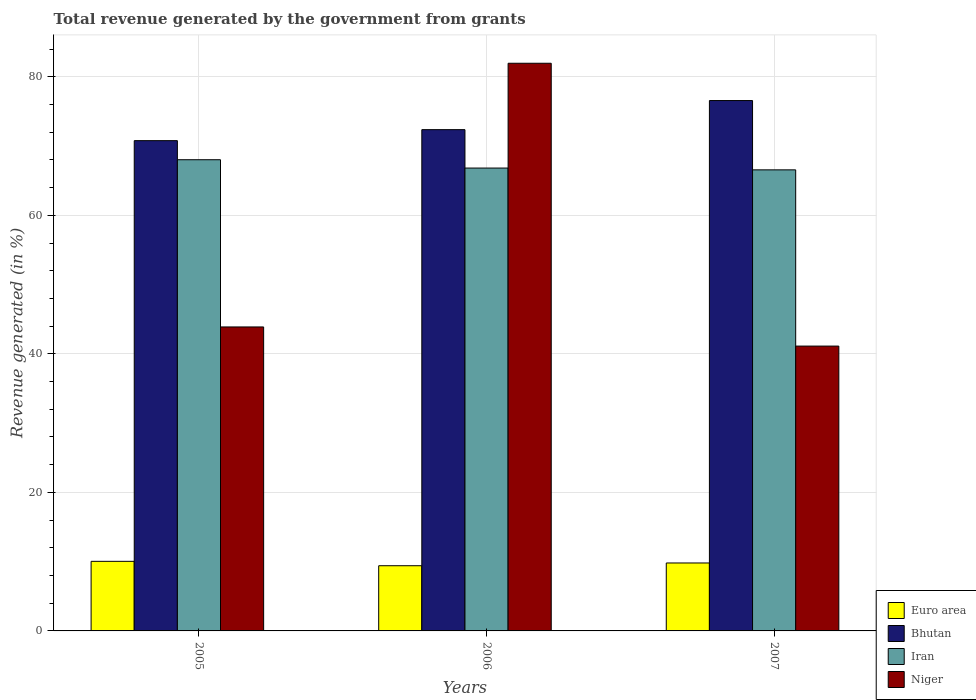How many groups of bars are there?
Your response must be concise. 3. Are the number of bars on each tick of the X-axis equal?
Your answer should be compact. Yes. How many bars are there on the 3rd tick from the left?
Provide a short and direct response. 4. How many bars are there on the 3rd tick from the right?
Make the answer very short. 4. What is the label of the 1st group of bars from the left?
Your response must be concise. 2005. What is the total revenue generated in Euro area in 2007?
Offer a very short reply. 9.81. Across all years, what is the maximum total revenue generated in Bhutan?
Offer a very short reply. 76.57. Across all years, what is the minimum total revenue generated in Niger?
Provide a short and direct response. 41.12. In which year was the total revenue generated in Niger maximum?
Provide a succinct answer. 2006. In which year was the total revenue generated in Iran minimum?
Your answer should be compact. 2007. What is the total total revenue generated in Iran in the graph?
Your answer should be compact. 201.42. What is the difference between the total revenue generated in Iran in 2006 and that in 2007?
Offer a terse response. 0.26. What is the difference between the total revenue generated in Bhutan in 2005 and the total revenue generated in Iran in 2006?
Your answer should be very brief. 3.96. What is the average total revenue generated in Bhutan per year?
Provide a succinct answer. 73.24. In the year 2006, what is the difference between the total revenue generated in Euro area and total revenue generated in Niger?
Ensure brevity in your answer.  -72.54. In how many years, is the total revenue generated in Niger greater than 20 %?
Offer a terse response. 3. What is the ratio of the total revenue generated in Iran in 2005 to that in 2007?
Provide a short and direct response. 1.02. Is the total revenue generated in Niger in 2005 less than that in 2006?
Provide a succinct answer. Yes. What is the difference between the highest and the second highest total revenue generated in Euro area?
Offer a terse response. 0.24. What is the difference between the highest and the lowest total revenue generated in Bhutan?
Offer a terse response. 5.79. Is the sum of the total revenue generated in Bhutan in 2006 and 2007 greater than the maximum total revenue generated in Niger across all years?
Give a very brief answer. Yes. What does the 3rd bar from the left in 2005 represents?
Ensure brevity in your answer.  Iran. What does the 2nd bar from the right in 2007 represents?
Your response must be concise. Iran. How many years are there in the graph?
Offer a very short reply. 3. Where does the legend appear in the graph?
Your answer should be very brief. Bottom right. How many legend labels are there?
Offer a terse response. 4. What is the title of the graph?
Provide a short and direct response. Total revenue generated by the government from grants. What is the label or title of the Y-axis?
Give a very brief answer. Revenue generated (in %). What is the Revenue generated (in %) in Euro area in 2005?
Give a very brief answer. 10.05. What is the Revenue generated (in %) of Bhutan in 2005?
Offer a very short reply. 70.78. What is the Revenue generated (in %) in Iran in 2005?
Your answer should be very brief. 68.03. What is the Revenue generated (in %) of Niger in 2005?
Provide a short and direct response. 43.89. What is the Revenue generated (in %) in Euro area in 2006?
Provide a succinct answer. 9.41. What is the Revenue generated (in %) of Bhutan in 2006?
Give a very brief answer. 72.37. What is the Revenue generated (in %) in Iran in 2006?
Offer a very short reply. 66.83. What is the Revenue generated (in %) of Niger in 2006?
Provide a short and direct response. 81.96. What is the Revenue generated (in %) of Euro area in 2007?
Offer a very short reply. 9.81. What is the Revenue generated (in %) in Bhutan in 2007?
Your answer should be compact. 76.57. What is the Revenue generated (in %) of Iran in 2007?
Your answer should be compact. 66.57. What is the Revenue generated (in %) of Niger in 2007?
Ensure brevity in your answer.  41.12. Across all years, what is the maximum Revenue generated (in %) of Euro area?
Ensure brevity in your answer.  10.05. Across all years, what is the maximum Revenue generated (in %) in Bhutan?
Your answer should be very brief. 76.57. Across all years, what is the maximum Revenue generated (in %) of Iran?
Make the answer very short. 68.03. Across all years, what is the maximum Revenue generated (in %) in Niger?
Ensure brevity in your answer.  81.96. Across all years, what is the minimum Revenue generated (in %) of Euro area?
Keep it short and to the point. 9.41. Across all years, what is the minimum Revenue generated (in %) of Bhutan?
Provide a succinct answer. 70.78. Across all years, what is the minimum Revenue generated (in %) of Iran?
Provide a short and direct response. 66.57. Across all years, what is the minimum Revenue generated (in %) in Niger?
Keep it short and to the point. 41.12. What is the total Revenue generated (in %) of Euro area in the graph?
Give a very brief answer. 29.27. What is the total Revenue generated (in %) of Bhutan in the graph?
Provide a short and direct response. 219.72. What is the total Revenue generated (in %) in Iran in the graph?
Keep it short and to the point. 201.42. What is the total Revenue generated (in %) of Niger in the graph?
Ensure brevity in your answer.  166.96. What is the difference between the Revenue generated (in %) in Euro area in 2005 and that in 2006?
Make the answer very short. 0.63. What is the difference between the Revenue generated (in %) of Bhutan in 2005 and that in 2006?
Make the answer very short. -1.59. What is the difference between the Revenue generated (in %) in Iran in 2005 and that in 2006?
Make the answer very short. 1.2. What is the difference between the Revenue generated (in %) of Niger in 2005 and that in 2006?
Your response must be concise. -38.07. What is the difference between the Revenue generated (in %) of Euro area in 2005 and that in 2007?
Offer a very short reply. 0.24. What is the difference between the Revenue generated (in %) in Bhutan in 2005 and that in 2007?
Make the answer very short. -5.79. What is the difference between the Revenue generated (in %) of Iran in 2005 and that in 2007?
Your response must be concise. 1.46. What is the difference between the Revenue generated (in %) in Niger in 2005 and that in 2007?
Your response must be concise. 2.76. What is the difference between the Revenue generated (in %) in Euro area in 2006 and that in 2007?
Your response must be concise. -0.4. What is the difference between the Revenue generated (in %) of Bhutan in 2006 and that in 2007?
Your answer should be compact. -4.2. What is the difference between the Revenue generated (in %) in Iran in 2006 and that in 2007?
Provide a succinct answer. 0.26. What is the difference between the Revenue generated (in %) of Niger in 2006 and that in 2007?
Your response must be concise. 40.83. What is the difference between the Revenue generated (in %) of Euro area in 2005 and the Revenue generated (in %) of Bhutan in 2006?
Provide a short and direct response. -62.33. What is the difference between the Revenue generated (in %) in Euro area in 2005 and the Revenue generated (in %) in Iran in 2006?
Ensure brevity in your answer.  -56.78. What is the difference between the Revenue generated (in %) in Euro area in 2005 and the Revenue generated (in %) in Niger in 2006?
Ensure brevity in your answer.  -71.91. What is the difference between the Revenue generated (in %) of Bhutan in 2005 and the Revenue generated (in %) of Iran in 2006?
Your answer should be compact. 3.96. What is the difference between the Revenue generated (in %) of Bhutan in 2005 and the Revenue generated (in %) of Niger in 2006?
Keep it short and to the point. -11.17. What is the difference between the Revenue generated (in %) of Iran in 2005 and the Revenue generated (in %) of Niger in 2006?
Ensure brevity in your answer.  -13.93. What is the difference between the Revenue generated (in %) of Euro area in 2005 and the Revenue generated (in %) of Bhutan in 2007?
Keep it short and to the point. -66.52. What is the difference between the Revenue generated (in %) of Euro area in 2005 and the Revenue generated (in %) of Iran in 2007?
Provide a short and direct response. -56.52. What is the difference between the Revenue generated (in %) in Euro area in 2005 and the Revenue generated (in %) in Niger in 2007?
Provide a succinct answer. -31.08. What is the difference between the Revenue generated (in %) in Bhutan in 2005 and the Revenue generated (in %) in Iran in 2007?
Offer a terse response. 4.22. What is the difference between the Revenue generated (in %) in Bhutan in 2005 and the Revenue generated (in %) in Niger in 2007?
Offer a terse response. 29.66. What is the difference between the Revenue generated (in %) of Iran in 2005 and the Revenue generated (in %) of Niger in 2007?
Make the answer very short. 26.9. What is the difference between the Revenue generated (in %) of Euro area in 2006 and the Revenue generated (in %) of Bhutan in 2007?
Keep it short and to the point. -67.16. What is the difference between the Revenue generated (in %) of Euro area in 2006 and the Revenue generated (in %) of Iran in 2007?
Keep it short and to the point. -57.15. What is the difference between the Revenue generated (in %) of Euro area in 2006 and the Revenue generated (in %) of Niger in 2007?
Make the answer very short. -31.71. What is the difference between the Revenue generated (in %) in Bhutan in 2006 and the Revenue generated (in %) in Iran in 2007?
Make the answer very short. 5.81. What is the difference between the Revenue generated (in %) of Bhutan in 2006 and the Revenue generated (in %) of Niger in 2007?
Keep it short and to the point. 31.25. What is the difference between the Revenue generated (in %) in Iran in 2006 and the Revenue generated (in %) in Niger in 2007?
Your answer should be very brief. 25.7. What is the average Revenue generated (in %) of Euro area per year?
Your response must be concise. 9.76. What is the average Revenue generated (in %) of Bhutan per year?
Offer a terse response. 73.24. What is the average Revenue generated (in %) of Iran per year?
Make the answer very short. 67.14. What is the average Revenue generated (in %) of Niger per year?
Offer a terse response. 55.65. In the year 2005, what is the difference between the Revenue generated (in %) in Euro area and Revenue generated (in %) in Bhutan?
Your response must be concise. -60.74. In the year 2005, what is the difference between the Revenue generated (in %) of Euro area and Revenue generated (in %) of Iran?
Provide a short and direct response. -57.98. In the year 2005, what is the difference between the Revenue generated (in %) of Euro area and Revenue generated (in %) of Niger?
Offer a terse response. -33.84. In the year 2005, what is the difference between the Revenue generated (in %) in Bhutan and Revenue generated (in %) in Iran?
Offer a terse response. 2.75. In the year 2005, what is the difference between the Revenue generated (in %) in Bhutan and Revenue generated (in %) in Niger?
Ensure brevity in your answer.  26.9. In the year 2005, what is the difference between the Revenue generated (in %) of Iran and Revenue generated (in %) of Niger?
Ensure brevity in your answer.  24.14. In the year 2006, what is the difference between the Revenue generated (in %) of Euro area and Revenue generated (in %) of Bhutan?
Offer a terse response. -62.96. In the year 2006, what is the difference between the Revenue generated (in %) in Euro area and Revenue generated (in %) in Iran?
Your answer should be compact. -57.41. In the year 2006, what is the difference between the Revenue generated (in %) of Euro area and Revenue generated (in %) of Niger?
Offer a very short reply. -72.54. In the year 2006, what is the difference between the Revenue generated (in %) in Bhutan and Revenue generated (in %) in Iran?
Provide a short and direct response. 5.55. In the year 2006, what is the difference between the Revenue generated (in %) of Bhutan and Revenue generated (in %) of Niger?
Keep it short and to the point. -9.58. In the year 2006, what is the difference between the Revenue generated (in %) of Iran and Revenue generated (in %) of Niger?
Offer a terse response. -15.13. In the year 2007, what is the difference between the Revenue generated (in %) of Euro area and Revenue generated (in %) of Bhutan?
Give a very brief answer. -66.76. In the year 2007, what is the difference between the Revenue generated (in %) of Euro area and Revenue generated (in %) of Iran?
Provide a succinct answer. -56.76. In the year 2007, what is the difference between the Revenue generated (in %) in Euro area and Revenue generated (in %) in Niger?
Your response must be concise. -31.31. In the year 2007, what is the difference between the Revenue generated (in %) of Bhutan and Revenue generated (in %) of Iran?
Your answer should be very brief. 10. In the year 2007, what is the difference between the Revenue generated (in %) in Bhutan and Revenue generated (in %) in Niger?
Make the answer very short. 35.45. In the year 2007, what is the difference between the Revenue generated (in %) of Iran and Revenue generated (in %) of Niger?
Offer a very short reply. 25.44. What is the ratio of the Revenue generated (in %) of Euro area in 2005 to that in 2006?
Provide a succinct answer. 1.07. What is the ratio of the Revenue generated (in %) in Bhutan in 2005 to that in 2006?
Your response must be concise. 0.98. What is the ratio of the Revenue generated (in %) of Iran in 2005 to that in 2006?
Keep it short and to the point. 1.02. What is the ratio of the Revenue generated (in %) of Niger in 2005 to that in 2006?
Your response must be concise. 0.54. What is the ratio of the Revenue generated (in %) of Euro area in 2005 to that in 2007?
Make the answer very short. 1.02. What is the ratio of the Revenue generated (in %) in Bhutan in 2005 to that in 2007?
Offer a very short reply. 0.92. What is the ratio of the Revenue generated (in %) in Niger in 2005 to that in 2007?
Ensure brevity in your answer.  1.07. What is the ratio of the Revenue generated (in %) in Euro area in 2006 to that in 2007?
Give a very brief answer. 0.96. What is the ratio of the Revenue generated (in %) of Bhutan in 2006 to that in 2007?
Your response must be concise. 0.95. What is the ratio of the Revenue generated (in %) in Iran in 2006 to that in 2007?
Offer a terse response. 1. What is the ratio of the Revenue generated (in %) of Niger in 2006 to that in 2007?
Offer a very short reply. 1.99. What is the difference between the highest and the second highest Revenue generated (in %) in Euro area?
Your answer should be very brief. 0.24. What is the difference between the highest and the second highest Revenue generated (in %) in Bhutan?
Ensure brevity in your answer.  4.2. What is the difference between the highest and the second highest Revenue generated (in %) in Iran?
Your answer should be very brief. 1.2. What is the difference between the highest and the second highest Revenue generated (in %) in Niger?
Your answer should be compact. 38.07. What is the difference between the highest and the lowest Revenue generated (in %) in Euro area?
Your answer should be compact. 0.63. What is the difference between the highest and the lowest Revenue generated (in %) in Bhutan?
Offer a terse response. 5.79. What is the difference between the highest and the lowest Revenue generated (in %) in Iran?
Your response must be concise. 1.46. What is the difference between the highest and the lowest Revenue generated (in %) of Niger?
Your answer should be very brief. 40.83. 